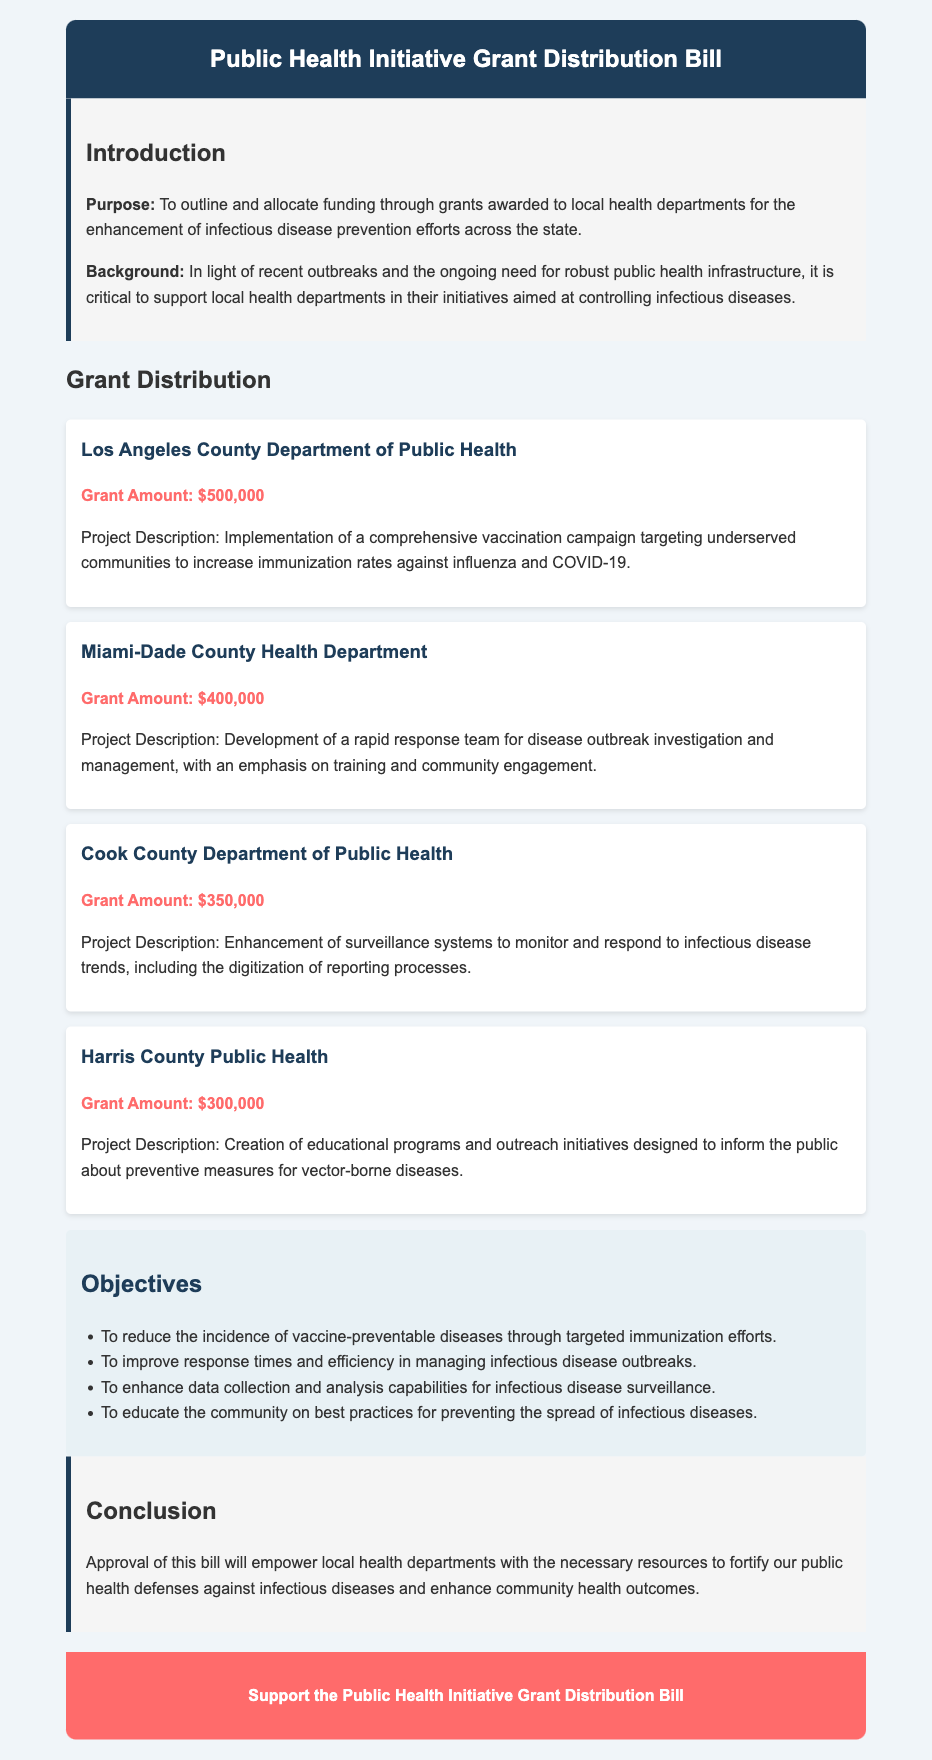What is the total amount awarded to Los Angeles County Department of Public Health? The grant amount for Los Angeles County Department of Public Health is stated directly in the document as $500,000.
Answer: $500,000 What is the primary objective of the grants? The primary objective is to enhance infectious disease prevention efforts, as outlined in the introduction section.
Answer: Enhance infectious disease prevention efforts How much funding was allocated to Harris County Public Health? The specific funding amount is mentioned for Harris County Public Health as $300,000 in the grant distribution section.
Answer: $300,000 What project intends to increase immunization rates against influenza and COVID-19? The project description for Los Angeles County Department of Public Health specifically mentions this aim.
Answer: Comprehensive vaccination campaign Which health department is involved in creating educational programs for vector-borne diseases? The project description in the document identifies Harris County Public Health as involved in this area.
Answer: Harris County Public Health How many objectives are outlined in the objectives section? The objectives section lists a total of four objectives related to infectious disease prevention efforts.
Answer: Four What is the total funding allocated for Cook County Department of Public Health? The grant amount for Cook County Department of Public Health is explicitly stated as $350,000 in the grant distribution section.
Answer: $350,000 What is the emphasis of the Miami-Dade County Health Department's project? The document specifies that the focus is on training and community engagement for outbreak investigation.
Answer: Training and community engagement What type of document is this? The structure and content indicate that this is a legislative bill addressing funding for public health initiatives.
Answer: Legislative bill 